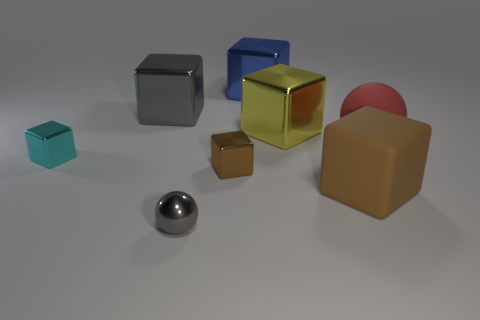Is the number of large red matte spheres greater than the number of big cyan metal balls?
Offer a very short reply. Yes. There is a yellow thing that is the same shape as the big blue thing; what is it made of?
Make the answer very short. Metal. Is the material of the yellow block the same as the large red object?
Give a very brief answer. No. Is the number of matte cubes in front of the big brown matte thing greater than the number of tiny brown shiny objects?
Offer a very short reply. No. There is a big red object behind the gray metal object in front of the big cube in front of the red rubber ball; what is it made of?
Make the answer very short. Rubber. How many things are either large brown blocks or large blocks that are in front of the big yellow block?
Provide a short and direct response. 1. Is the color of the big cube that is in front of the red object the same as the large matte sphere?
Give a very brief answer. No. Are there more gray blocks to the left of the large sphere than small brown things that are behind the tiny gray sphere?
Your answer should be very brief. No. Are there any other things that are the same color as the tiny metallic ball?
Offer a very short reply. Yes. What number of objects are cyan objects or large rubber objects?
Your response must be concise. 3. 